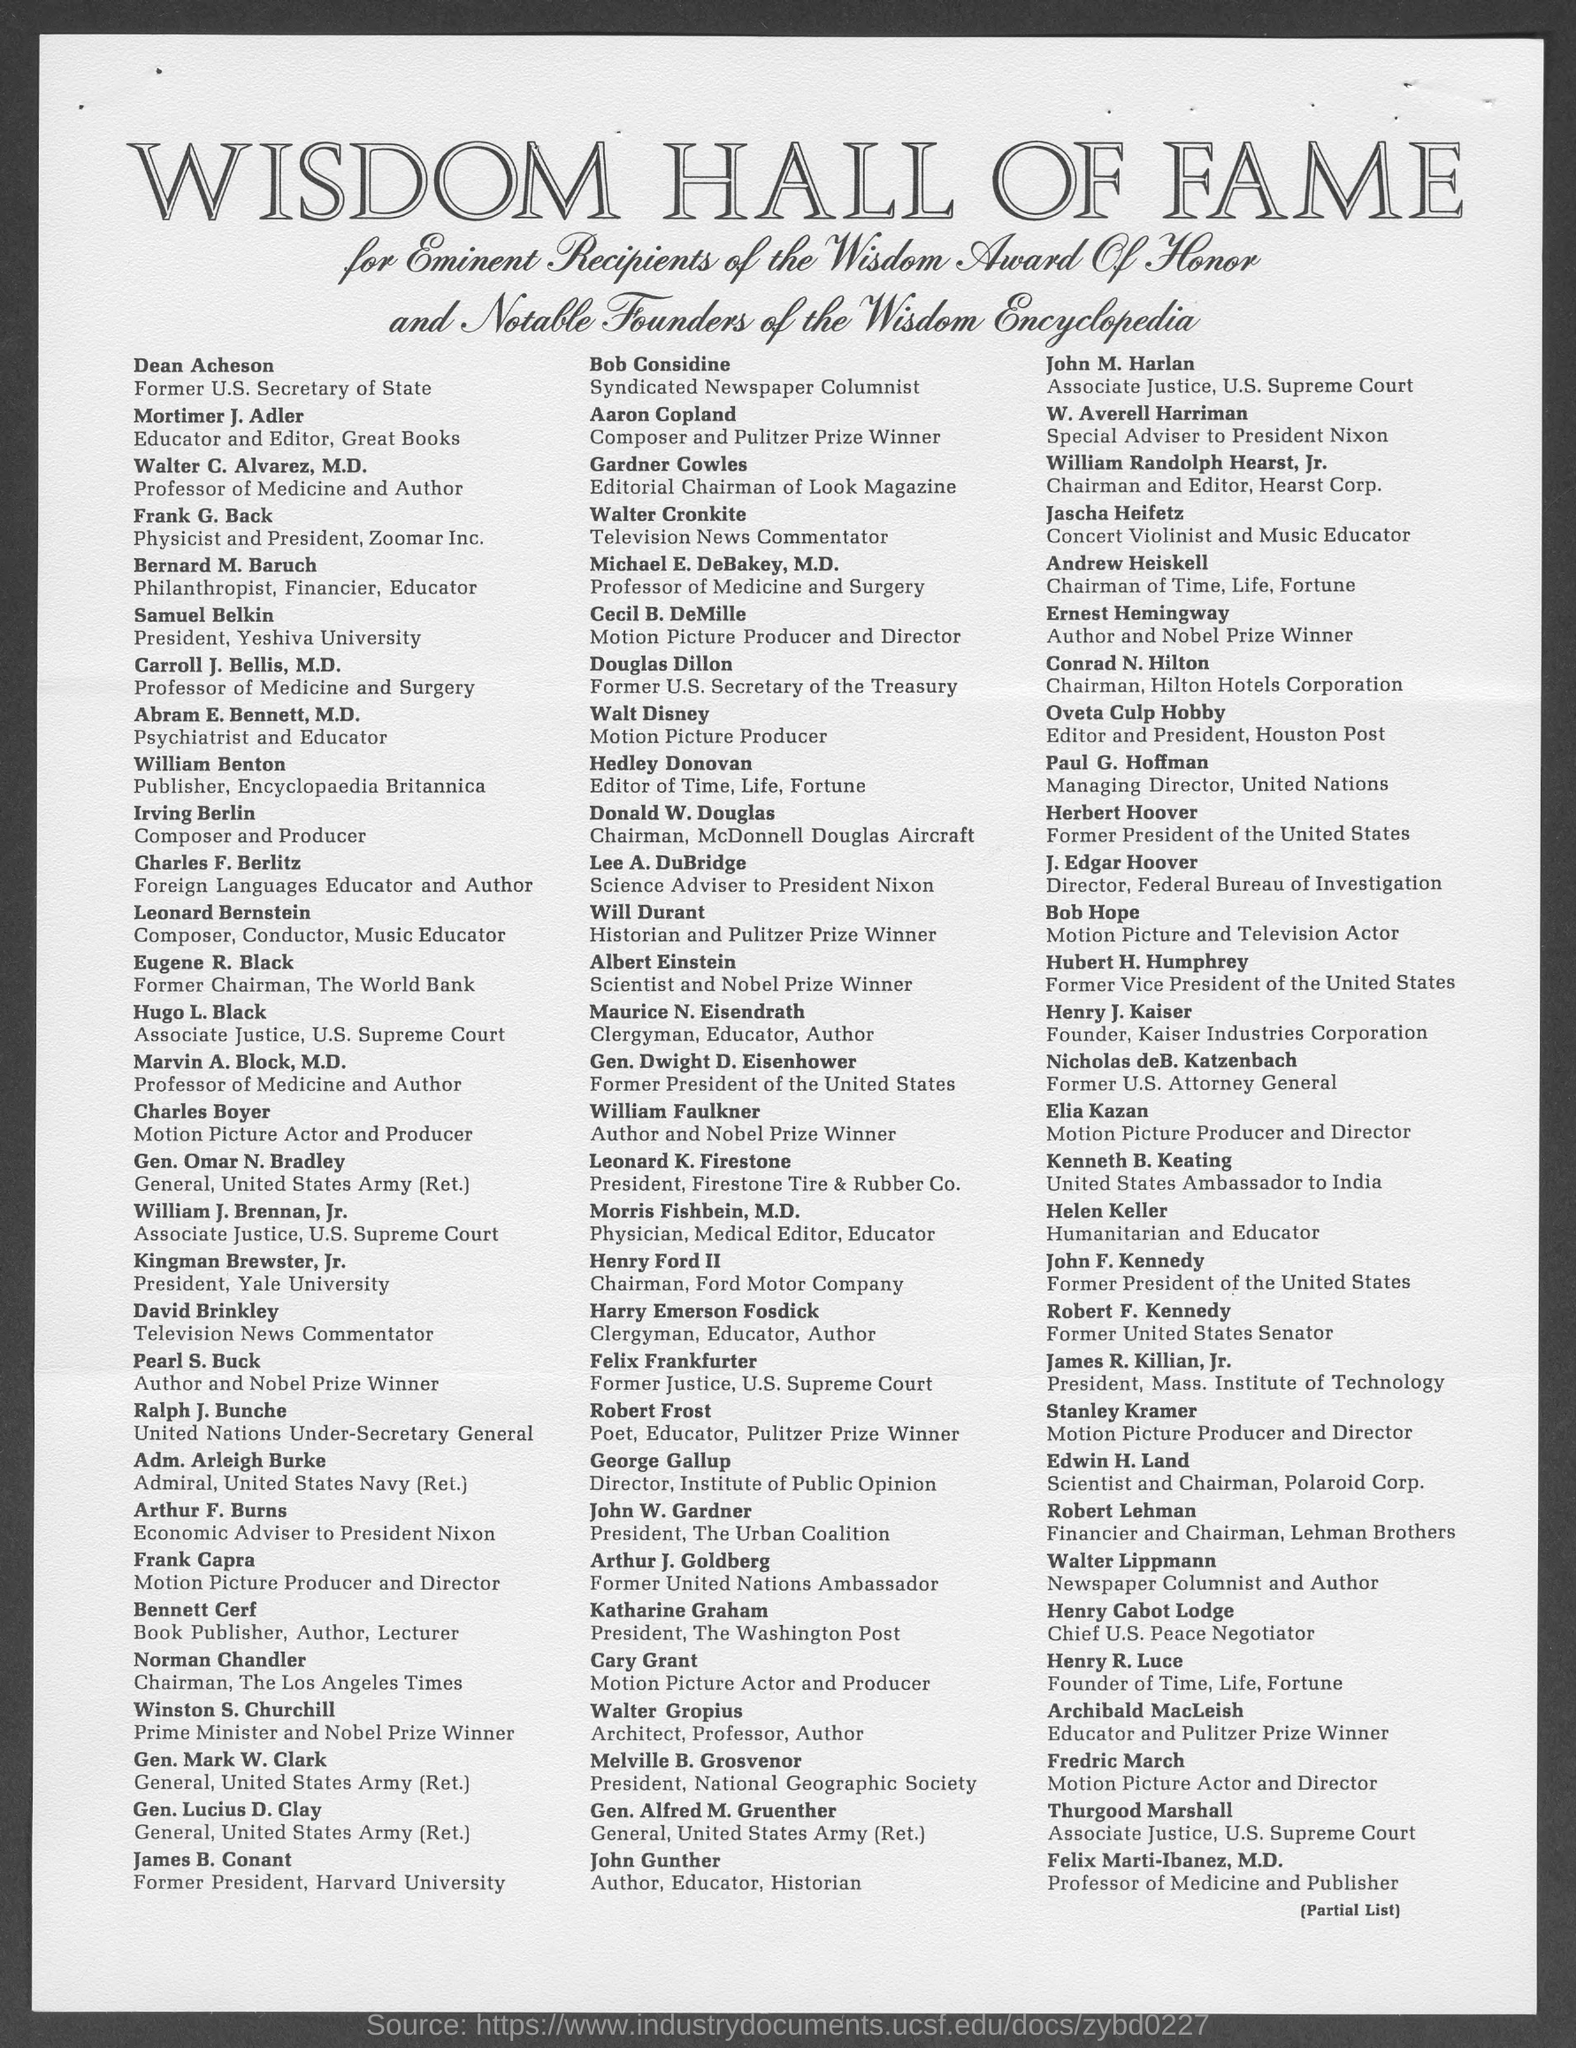What is the designation of dean acheson as mentioned in the given page ?
Provide a short and direct response. Former u.s. secretary of state. What is the designation of frank g. back  as mentioned in the given page ?
Offer a very short reply. Physicist and president, zoomar inc. What is the designation of conard n. hilton as mentioned in the given page ?
Your answer should be very brief. Chairman, hilton hotels corporation. What is the designation of paul g. hoffman as mentioned in the given page ?
Provide a succinct answer. Managing director, united nations. What is the designation of hubert h. humphery as mentioned in the given page ?
Offer a terse response. Former vice president of the united states. What is the designation of george gallup as mentioned in the given page ?
Give a very brief answer. Director, institute of public opinion. What is the designation of katharine graham as mentioned in the given page ?
Your answer should be very brief. President, the washington post. 